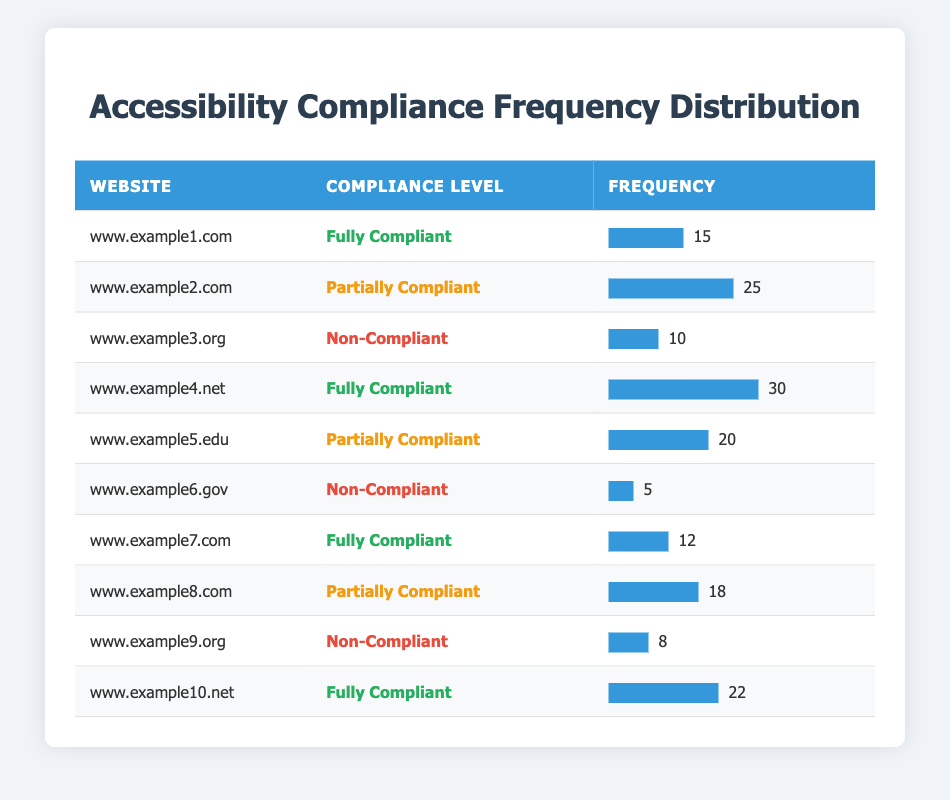What is the website with the highest frequency of compliance? The website with the highest frequency can be found by comparing the "Frequency" values. "www.example4.net" has a frequency of 30, which is higher than any other website's frequency in the table.
Answer: www.example4.net How many websites are fully compliant? Count the number of entries where the "Compliance Level" is "Fully Compliant". There are three instances: "www.example1.com", "www.example4.net", and "www.example10.net".
Answer: 3 What is the total frequency of partially compliant websites? To find the total, add the frequencies of all entries with "Partially Compliant". These are 25 (www.example2.com) + 20 (www.example5.edu) + 18 (www.example8.com) = 63.
Answer: 63 Is "www.example6.gov" compliant with accessibility guidelines? Check the "Compliance Level" for "www.example6.gov", which is "Non-Compliant". This indicates that the website does not meet the accessibility guidelines.
Answer: No What is the average frequency for non-compliant websites? The frequencies for non-compliant websites are 10 (www.example3.org), 5 (www.example6.gov), and 8 (www.example9.org). First, add these frequencies: 10 + 5 + 8 = 23. Then, divide by the number of non-compliant websites (3): 23 / 3 = approximately 7.67.
Answer: 7.67 Which compliance level has the lowest frequency, and what is that frequency? Identify the minimum frequency from the table. The lowest frequency is found under "Non-Compliant" with a frequency of 5 from the website "www.example6.gov".
Answer: Non-Compliant, 5 How many websites have a frequency of more than 20? Count the frequencies greater than 20. The frequencies are: 30 (www.example4.net), 25 (www.example2.com), and 22 (www.example10.net), totaling three websites.
Answer: 3 If we consider only fully compliant websites, what is the total frequency? Add the frequencies of the fully compliant websites: 15 (www.example1.com) + 30 (www.example4.net) + 12 (www.example7.com) + 22 (www.example10.net). The sum is 15 + 30 + 12 + 22 = 79.
Answer: 79 